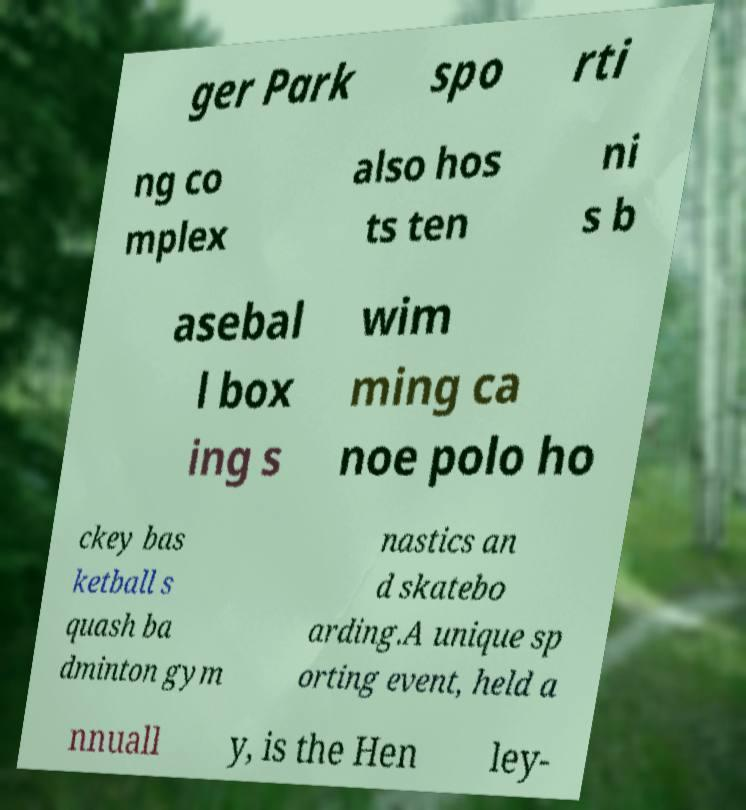Could you assist in decoding the text presented in this image and type it out clearly? ger Park spo rti ng co mplex also hos ts ten ni s b asebal l box ing s wim ming ca noe polo ho ckey bas ketball s quash ba dminton gym nastics an d skatebo arding.A unique sp orting event, held a nnuall y, is the Hen ley- 